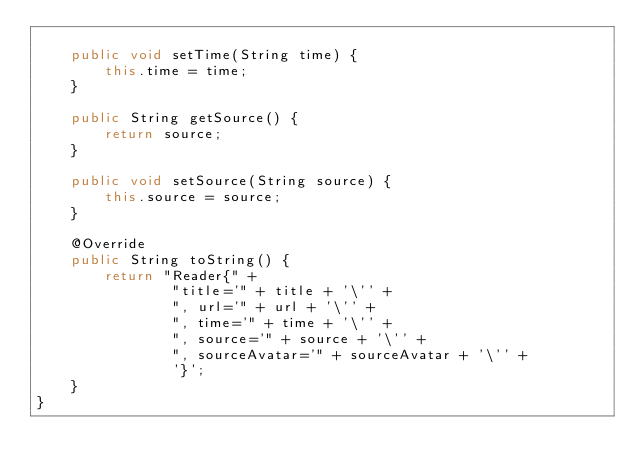Convert code to text. <code><loc_0><loc_0><loc_500><loc_500><_Java_>
    public void setTime(String time) {
        this.time = time;
    }

    public String getSource() {
        return source;
    }

    public void setSource(String source) {
        this.source = source;
    }

    @Override
    public String toString() {
        return "Reader{" +
                "title='" + title + '\'' +
                ", url='" + url + '\'' +
                ", time='" + time + '\'' +
                ", source='" + source + '\'' +
                ", sourceAvatar='" + sourceAvatar + '\'' +
                '}';
    }
}
</code> 